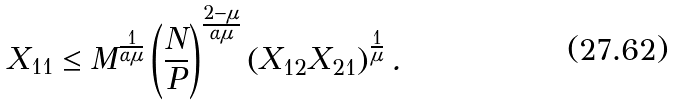Convert formula to latex. <formula><loc_0><loc_0><loc_500><loc_500>X _ { 1 1 } \leq M ^ { \frac { 1 } { \alpha \mu } } \left ( \frac { N } { P } \right ) ^ { \frac { 2 - \mu } { \alpha \mu } } \left ( X _ { 1 2 } X _ { 2 1 } \right ) ^ { \frac { 1 } { \mu } } .</formula> 